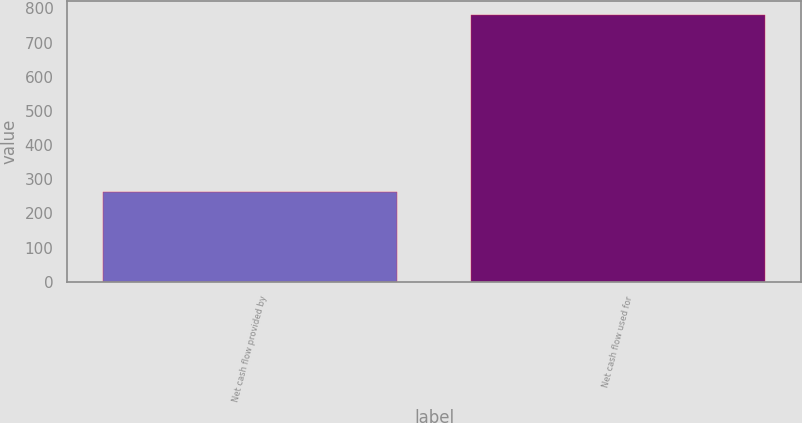Convert chart to OTSL. <chart><loc_0><loc_0><loc_500><loc_500><bar_chart><fcel>Net cash flow provided by<fcel>Net cash flow used for<nl><fcel>262.4<fcel>781.4<nl></chart> 